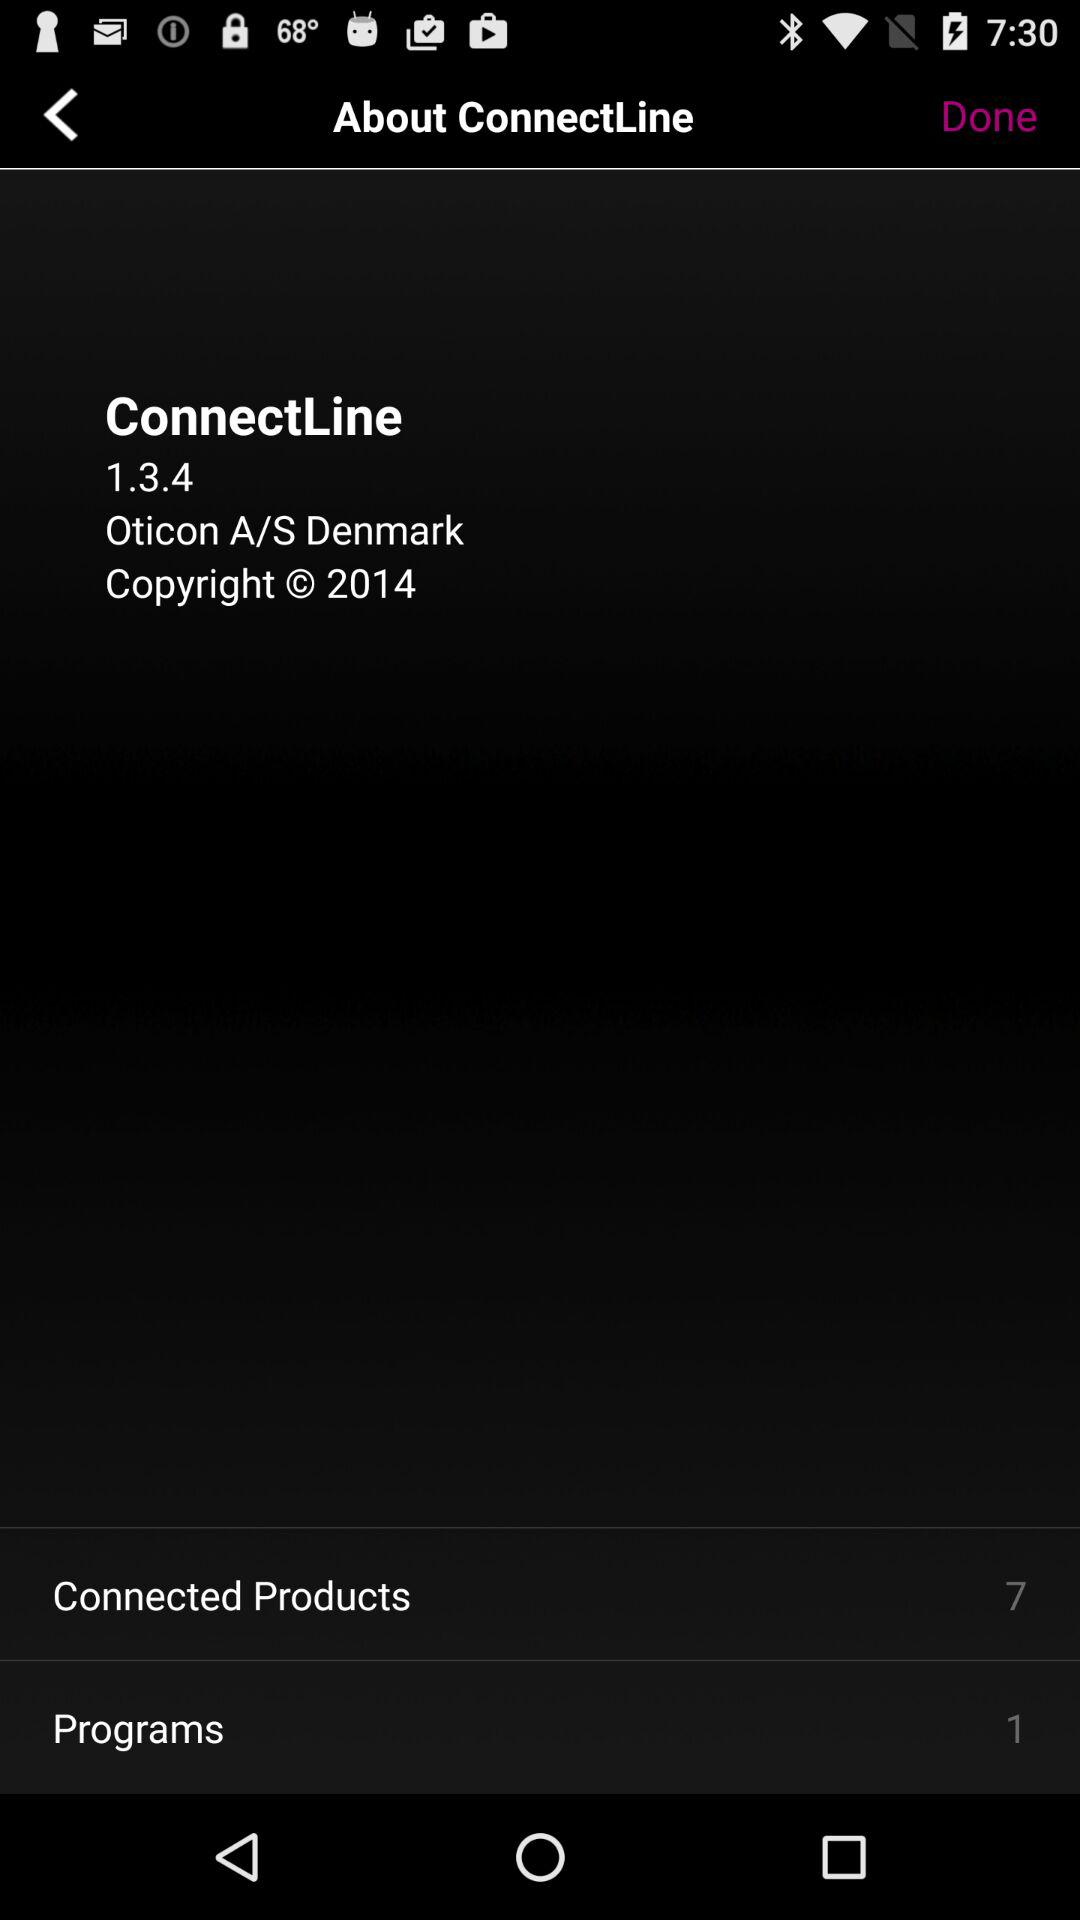How many programs are displayed on the screen? There is 1 program. 